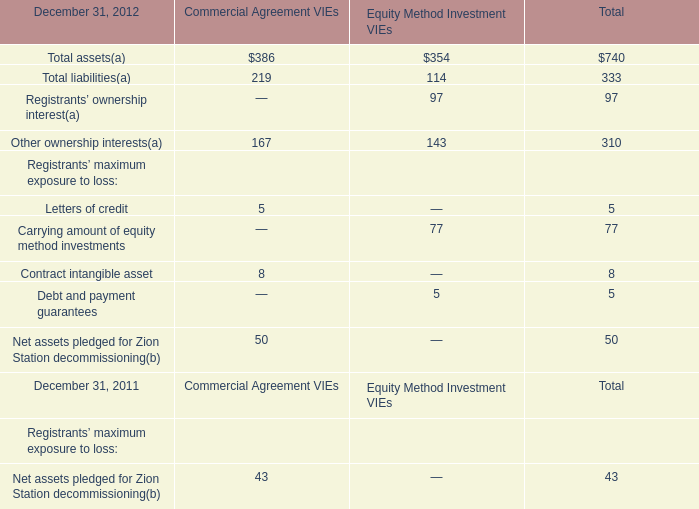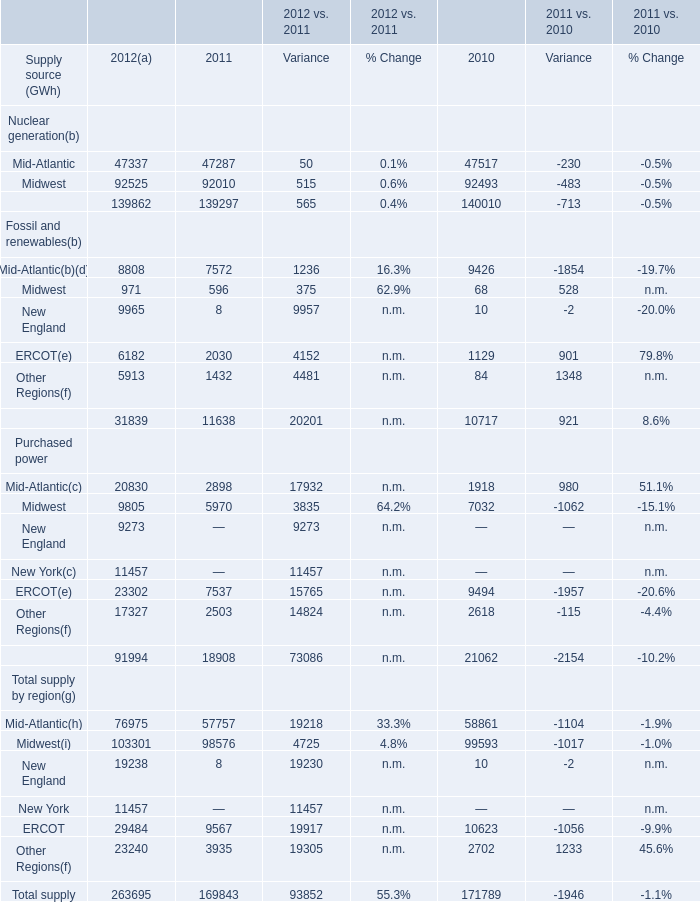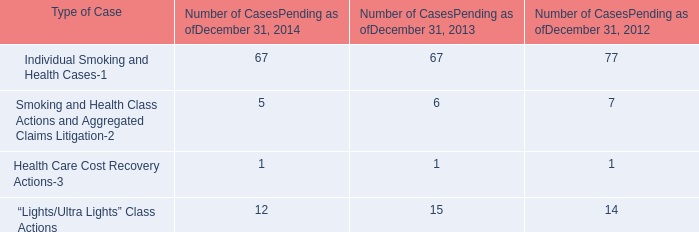What will Supply from Fossil and renewables reach in 2013 if it continues to grow at its current rate? (in GWh) 
Computations: (31839 * (1 + ((31839 - 11638) / 11638)))
Answer: 87104.47852. 